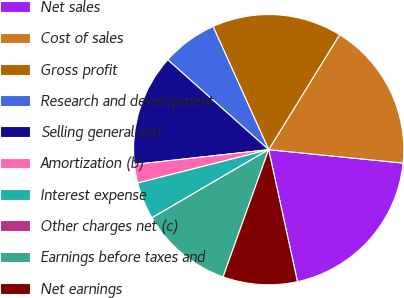Convert chart. <chart><loc_0><loc_0><loc_500><loc_500><pie_chart><fcel>Net sales<fcel>Cost of sales<fcel>Gross profit<fcel>Research and development<fcel>Selling general and<fcel>Amortization (b)<fcel>Interest expense<fcel>Other charges net (c)<fcel>Earnings before taxes and<fcel>Net earnings<nl><fcel>20.0%<fcel>17.78%<fcel>15.55%<fcel>6.67%<fcel>13.33%<fcel>2.22%<fcel>4.45%<fcel>0.0%<fcel>11.11%<fcel>8.89%<nl></chart> 